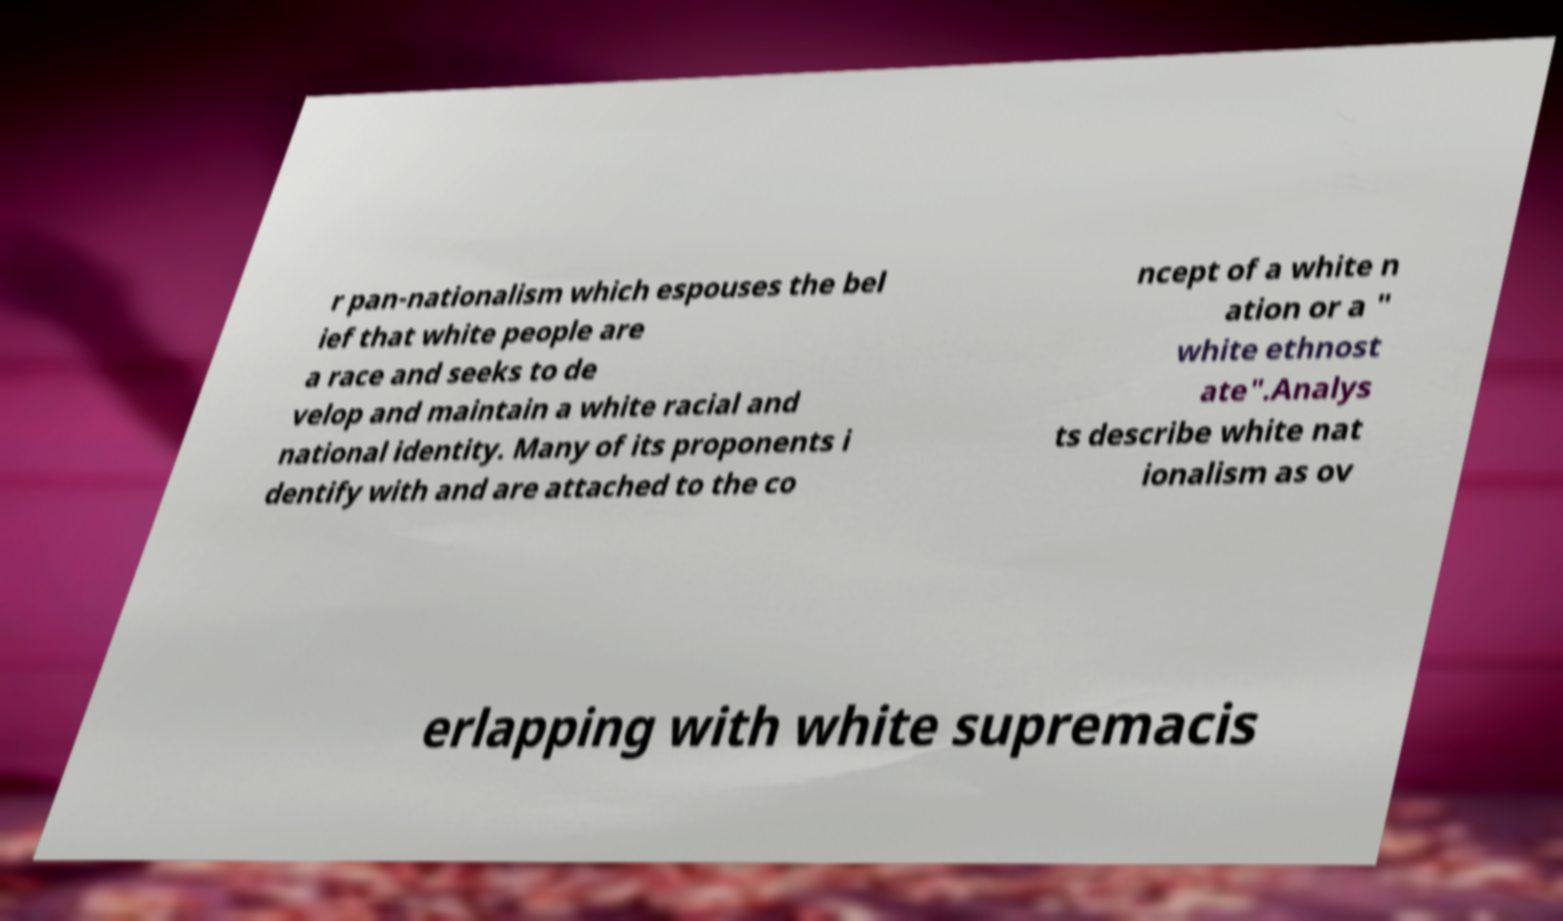There's text embedded in this image that I need extracted. Can you transcribe it verbatim? r pan-nationalism which espouses the bel ief that white people are a race and seeks to de velop and maintain a white racial and national identity. Many of its proponents i dentify with and are attached to the co ncept of a white n ation or a " white ethnost ate".Analys ts describe white nat ionalism as ov erlapping with white supremacis 